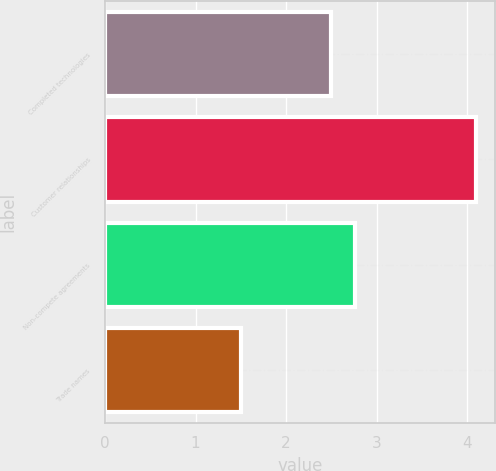Convert chart. <chart><loc_0><loc_0><loc_500><loc_500><bar_chart><fcel>Completed technologies<fcel>Customer relationships<fcel>Non-compete agreements<fcel>Trade names<nl><fcel>2.5<fcel>4.1<fcel>2.76<fcel>1.5<nl></chart> 